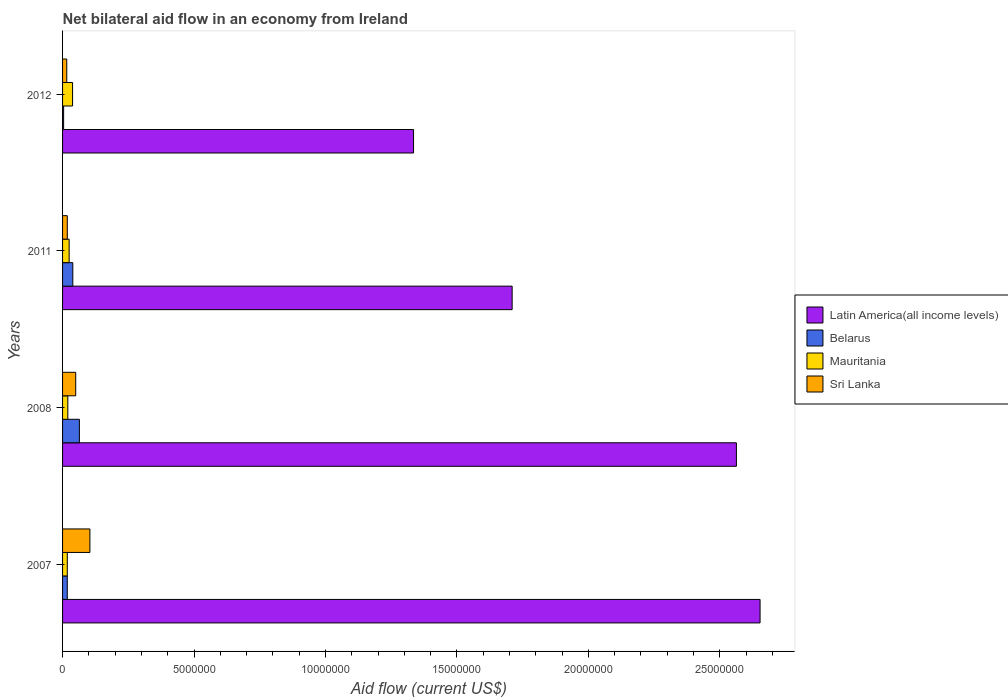How many groups of bars are there?
Make the answer very short. 4. Are the number of bars on each tick of the Y-axis equal?
Ensure brevity in your answer.  Yes. How many bars are there on the 2nd tick from the bottom?
Your answer should be compact. 4. In how many cases, is the number of bars for a given year not equal to the number of legend labels?
Give a very brief answer. 0. What is the net bilateral aid flow in Belarus in 2012?
Provide a succinct answer. 4.00e+04. Across all years, what is the minimum net bilateral aid flow in Mauritania?
Make the answer very short. 1.80e+05. In which year was the net bilateral aid flow in Sri Lanka minimum?
Make the answer very short. 2012. What is the total net bilateral aid flow in Belarus in the graph?
Offer a very short reply. 1.25e+06. What is the difference between the net bilateral aid flow in Latin America(all income levels) in 2007 and that in 2012?
Make the answer very short. 1.32e+07. What is the difference between the net bilateral aid flow in Latin America(all income levels) in 2011 and the net bilateral aid flow in Sri Lanka in 2007?
Your response must be concise. 1.61e+07. What is the average net bilateral aid flow in Belarus per year?
Offer a very short reply. 3.12e+05. What is the ratio of the net bilateral aid flow in Latin America(all income levels) in 2007 to that in 2008?
Offer a terse response. 1.04. Is the net bilateral aid flow in Mauritania in 2008 less than that in 2011?
Provide a succinct answer. Yes. What is the difference between the highest and the second highest net bilateral aid flow in Sri Lanka?
Provide a short and direct response. 5.40e+05. What is the difference between the highest and the lowest net bilateral aid flow in Mauritania?
Provide a short and direct response. 2.00e+05. In how many years, is the net bilateral aid flow in Latin America(all income levels) greater than the average net bilateral aid flow in Latin America(all income levels) taken over all years?
Give a very brief answer. 2. Is the sum of the net bilateral aid flow in Belarus in 2008 and 2011 greater than the maximum net bilateral aid flow in Latin America(all income levels) across all years?
Offer a very short reply. No. Is it the case that in every year, the sum of the net bilateral aid flow in Belarus and net bilateral aid flow in Sri Lanka is greater than the sum of net bilateral aid flow in Mauritania and net bilateral aid flow in Latin America(all income levels)?
Ensure brevity in your answer.  No. What does the 1st bar from the top in 2007 represents?
Your answer should be compact. Sri Lanka. What does the 1st bar from the bottom in 2007 represents?
Keep it short and to the point. Latin America(all income levels). Is it the case that in every year, the sum of the net bilateral aid flow in Latin America(all income levels) and net bilateral aid flow in Mauritania is greater than the net bilateral aid flow in Belarus?
Your answer should be very brief. Yes. How many bars are there?
Offer a terse response. 16. Are all the bars in the graph horizontal?
Your answer should be compact. Yes. What is the difference between two consecutive major ticks on the X-axis?
Provide a succinct answer. 5.00e+06. Are the values on the major ticks of X-axis written in scientific E-notation?
Make the answer very short. No. Does the graph contain any zero values?
Your answer should be very brief. No. How are the legend labels stacked?
Make the answer very short. Vertical. What is the title of the graph?
Provide a succinct answer. Net bilateral aid flow in an economy from Ireland. Does "South Asia" appear as one of the legend labels in the graph?
Provide a succinct answer. No. What is the label or title of the X-axis?
Offer a very short reply. Aid flow (current US$). What is the Aid flow (current US$) of Latin America(all income levels) in 2007?
Provide a succinct answer. 2.65e+07. What is the Aid flow (current US$) of Belarus in 2007?
Give a very brief answer. 1.80e+05. What is the Aid flow (current US$) in Mauritania in 2007?
Ensure brevity in your answer.  1.80e+05. What is the Aid flow (current US$) in Sri Lanka in 2007?
Give a very brief answer. 1.04e+06. What is the Aid flow (current US$) of Latin America(all income levels) in 2008?
Offer a very short reply. 2.56e+07. What is the Aid flow (current US$) of Belarus in 2008?
Ensure brevity in your answer.  6.40e+05. What is the Aid flow (current US$) in Sri Lanka in 2008?
Your answer should be very brief. 5.00e+05. What is the Aid flow (current US$) of Latin America(all income levels) in 2011?
Make the answer very short. 1.71e+07. What is the Aid flow (current US$) of Sri Lanka in 2011?
Give a very brief answer. 1.80e+05. What is the Aid flow (current US$) of Latin America(all income levels) in 2012?
Make the answer very short. 1.34e+07. What is the Aid flow (current US$) in Belarus in 2012?
Your answer should be very brief. 4.00e+04. Across all years, what is the maximum Aid flow (current US$) of Latin America(all income levels)?
Keep it short and to the point. 2.65e+07. Across all years, what is the maximum Aid flow (current US$) in Belarus?
Offer a terse response. 6.40e+05. Across all years, what is the maximum Aid flow (current US$) of Mauritania?
Make the answer very short. 3.80e+05. Across all years, what is the maximum Aid flow (current US$) of Sri Lanka?
Provide a succinct answer. 1.04e+06. Across all years, what is the minimum Aid flow (current US$) of Latin America(all income levels)?
Your answer should be compact. 1.34e+07. What is the total Aid flow (current US$) of Latin America(all income levels) in the graph?
Provide a short and direct response. 8.26e+07. What is the total Aid flow (current US$) of Belarus in the graph?
Make the answer very short. 1.25e+06. What is the total Aid flow (current US$) in Mauritania in the graph?
Keep it short and to the point. 1.01e+06. What is the total Aid flow (current US$) of Sri Lanka in the graph?
Your response must be concise. 1.88e+06. What is the difference between the Aid flow (current US$) of Belarus in 2007 and that in 2008?
Offer a very short reply. -4.60e+05. What is the difference between the Aid flow (current US$) of Mauritania in 2007 and that in 2008?
Your answer should be compact. -2.00e+04. What is the difference between the Aid flow (current US$) in Sri Lanka in 2007 and that in 2008?
Your answer should be compact. 5.40e+05. What is the difference between the Aid flow (current US$) in Latin America(all income levels) in 2007 and that in 2011?
Ensure brevity in your answer.  9.43e+06. What is the difference between the Aid flow (current US$) in Mauritania in 2007 and that in 2011?
Your answer should be compact. -7.00e+04. What is the difference between the Aid flow (current US$) of Sri Lanka in 2007 and that in 2011?
Offer a terse response. 8.60e+05. What is the difference between the Aid flow (current US$) of Latin America(all income levels) in 2007 and that in 2012?
Your response must be concise. 1.32e+07. What is the difference between the Aid flow (current US$) in Mauritania in 2007 and that in 2012?
Provide a short and direct response. -2.00e+05. What is the difference between the Aid flow (current US$) of Sri Lanka in 2007 and that in 2012?
Your answer should be compact. 8.80e+05. What is the difference between the Aid flow (current US$) in Latin America(all income levels) in 2008 and that in 2011?
Keep it short and to the point. 8.53e+06. What is the difference between the Aid flow (current US$) in Latin America(all income levels) in 2008 and that in 2012?
Give a very brief answer. 1.23e+07. What is the difference between the Aid flow (current US$) of Belarus in 2008 and that in 2012?
Your answer should be compact. 6.00e+05. What is the difference between the Aid flow (current US$) in Sri Lanka in 2008 and that in 2012?
Ensure brevity in your answer.  3.40e+05. What is the difference between the Aid flow (current US$) in Latin America(all income levels) in 2011 and that in 2012?
Keep it short and to the point. 3.75e+06. What is the difference between the Aid flow (current US$) in Belarus in 2011 and that in 2012?
Keep it short and to the point. 3.50e+05. What is the difference between the Aid flow (current US$) of Sri Lanka in 2011 and that in 2012?
Keep it short and to the point. 2.00e+04. What is the difference between the Aid flow (current US$) of Latin America(all income levels) in 2007 and the Aid flow (current US$) of Belarus in 2008?
Your answer should be compact. 2.59e+07. What is the difference between the Aid flow (current US$) of Latin America(all income levels) in 2007 and the Aid flow (current US$) of Mauritania in 2008?
Keep it short and to the point. 2.63e+07. What is the difference between the Aid flow (current US$) of Latin America(all income levels) in 2007 and the Aid flow (current US$) of Sri Lanka in 2008?
Offer a terse response. 2.60e+07. What is the difference between the Aid flow (current US$) in Belarus in 2007 and the Aid flow (current US$) in Mauritania in 2008?
Make the answer very short. -2.00e+04. What is the difference between the Aid flow (current US$) in Belarus in 2007 and the Aid flow (current US$) in Sri Lanka in 2008?
Provide a short and direct response. -3.20e+05. What is the difference between the Aid flow (current US$) in Mauritania in 2007 and the Aid flow (current US$) in Sri Lanka in 2008?
Ensure brevity in your answer.  -3.20e+05. What is the difference between the Aid flow (current US$) of Latin America(all income levels) in 2007 and the Aid flow (current US$) of Belarus in 2011?
Offer a terse response. 2.61e+07. What is the difference between the Aid flow (current US$) in Latin America(all income levels) in 2007 and the Aid flow (current US$) in Mauritania in 2011?
Your answer should be very brief. 2.63e+07. What is the difference between the Aid flow (current US$) of Latin America(all income levels) in 2007 and the Aid flow (current US$) of Sri Lanka in 2011?
Your response must be concise. 2.64e+07. What is the difference between the Aid flow (current US$) of Latin America(all income levels) in 2007 and the Aid flow (current US$) of Belarus in 2012?
Give a very brief answer. 2.65e+07. What is the difference between the Aid flow (current US$) of Latin America(all income levels) in 2007 and the Aid flow (current US$) of Mauritania in 2012?
Offer a very short reply. 2.62e+07. What is the difference between the Aid flow (current US$) in Latin America(all income levels) in 2007 and the Aid flow (current US$) in Sri Lanka in 2012?
Provide a short and direct response. 2.64e+07. What is the difference between the Aid flow (current US$) in Latin America(all income levels) in 2008 and the Aid flow (current US$) in Belarus in 2011?
Your answer should be compact. 2.52e+07. What is the difference between the Aid flow (current US$) in Latin America(all income levels) in 2008 and the Aid flow (current US$) in Mauritania in 2011?
Make the answer very short. 2.54e+07. What is the difference between the Aid flow (current US$) in Latin America(all income levels) in 2008 and the Aid flow (current US$) in Sri Lanka in 2011?
Provide a succinct answer. 2.54e+07. What is the difference between the Aid flow (current US$) of Latin America(all income levels) in 2008 and the Aid flow (current US$) of Belarus in 2012?
Ensure brevity in your answer.  2.56e+07. What is the difference between the Aid flow (current US$) in Latin America(all income levels) in 2008 and the Aid flow (current US$) in Mauritania in 2012?
Make the answer very short. 2.52e+07. What is the difference between the Aid flow (current US$) of Latin America(all income levels) in 2008 and the Aid flow (current US$) of Sri Lanka in 2012?
Offer a very short reply. 2.55e+07. What is the difference between the Aid flow (current US$) in Mauritania in 2008 and the Aid flow (current US$) in Sri Lanka in 2012?
Make the answer very short. 4.00e+04. What is the difference between the Aid flow (current US$) in Latin America(all income levels) in 2011 and the Aid flow (current US$) in Belarus in 2012?
Provide a succinct answer. 1.71e+07. What is the difference between the Aid flow (current US$) in Latin America(all income levels) in 2011 and the Aid flow (current US$) in Mauritania in 2012?
Your answer should be very brief. 1.67e+07. What is the difference between the Aid flow (current US$) in Latin America(all income levels) in 2011 and the Aid flow (current US$) in Sri Lanka in 2012?
Provide a succinct answer. 1.69e+07. What is the difference between the Aid flow (current US$) of Mauritania in 2011 and the Aid flow (current US$) of Sri Lanka in 2012?
Give a very brief answer. 9.00e+04. What is the average Aid flow (current US$) in Latin America(all income levels) per year?
Ensure brevity in your answer.  2.07e+07. What is the average Aid flow (current US$) in Belarus per year?
Your answer should be very brief. 3.12e+05. What is the average Aid flow (current US$) of Mauritania per year?
Ensure brevity in your answer.  2.52e+05. What is the average Aid flow (current US$) in Sri Lanka per year?
Give a very brief answer. 4.70e+05. In the year 2007, what is the difference between the Aid flow (current US$) in Latin America(all income levels) and Aid flow (current US$) in Belarus?
Your answer should be compact. 2.64e+07. In the year 2007, what is the difference between the Aid flow (current US$) in Latin America(all income levels) and Aid flow (current US$) in Mauritania?
Offer a very short reply. 2.64e+07. In the year 2007, what is the difference between the Aid flow (current US$) of Latin America(all income levels) and Aid flow (current US$) of Sri Lanka?
Your answer should be very brief. 2.55e+07. In the year 2007, what is the difference between the Aid flow (current US$) in Belarus and Aid flow (current US$) in Mauritania?
Make the answer very short. 0. In the year 2007, what is the difference between the Aid flow (current US$) in Belarus and Aid flow (current US$) in Sri Lanka?
Your answer should be compact. -8.60e+05. In the year 2007, what is the difference between the Aid flow (current US$) of Mauritania and Aid flow (current US$) of Sri Lanka?
Provide a short and direct response. -8.60e+05. In the year 2008, what is the difference between the Aid flow (current US$) of Latin America(all income levels) and Aid flow (current US$) of Belarus?
Your answer should be very brief. 2.50e+07. In the year 2008, what is the difference between the Aid flow (current US$) of Latin America(all income levels) and Aid flow (current US$) of Mauritania?
Keep it short and to the point. 2.54e+07. In the year 2008, what is the difference between the Aid flow (current US$) of Latin America(all income levels) and Aid flow (current US$) of Sri Lanka?
Ensure brevity in your answer.  2.51e+07. In the year 2008, what is the difference between the Aid flow (current US$) of Belarus and Aid flow (current US$) of Mauritania?
Provide a succinct answer. 4.40e+05. In the year 2011, what is the difference between the Aid flow (current US$) in Latin America(all income levels) and Aid flow (current US$) in Belarus?
Keep it short and to the point. 1.67e+07. In the year 2011, what is the difference between the Aid flow (current US$) of Latin America(all income levels) and Aid flow (current US$) of Mauritania?
Your answer should be very brief. 1.68e+07. In the year 2011, what is the difference between the Aid flow (current US$) in Latin America(all income levels) and Aid flow (current US$) in Sri Lanka?
Your answer should be very brief. 1.69e+07. In the year 2012, what is the difference between the Aid flow (current US$) in Latin America(all income levels) and Aid flow (current US$) in Belarus?
Ensure brevity in your answer.  1.33e+07. In the year 2012, what is the difference between the Aid flow (current US$) of Latin America(all income levels) and Aid flow (current US$) of Mauritania?
Make the answer very short. 1.30e+07. In the year 2012, what is the difference between the Aid flow (current US$) in Latin America(all income levels) and Aid flow (current US$) in Sri Lanka?
Make the answer very short. 1.32e+07. In the year 2012, what is the difference between the Aid flow (current US$) of Belarus and Aid flow (current US$) of Sri Lanka?
Keep it short and to the point. -1.20e+05. In the year 2012, what is the difference between the Aid flow (current US$) of Mauritania and Aid flow (current US$) of Sri Lanka?
Make the answer very short. 2.20e+05. What is the ratio of the Aid flow (current US$) of Latin America(all income levels) in 2007 to that in 2008?
Your answer should be compact. 1.04. What is the ratio of the Aid flow (current US$) in Belarus in 2007 to that in 2008?
Your response must be concise. 0.28. What is the ratio of the Aid flow (current US$) of Sri Lanka in 2007 to that in 2008?
Offer a terse response. 2.08. What is the ratio of the Aid flow (current US$) of Latin America(all income levels) in 2007 to that in 2011?
Give a very brief answer. 1.55. What is the ratio of the Aid flow (current US$) in Belarus in 2007 to that in 2011?
Provide a short and direct response. 0.46. What is the ratio of the Aid flow (current US$) in Mauritania in 2007 to that in 2011?
Your response must be concise. 0.72. What is the ratio of the Aid flow (current US$) of Sri Lanka in 2007 to that in 2011?
Your answer should be compact. 5.78. What is the ratio of the Aid flow (current US$) in Latin America(all income levels) in 2007 to that in 2012?
Ensure brevity in your answer.  1.99. What is the ratio of the Aid flow (current US$) of Mauritania in 2007 to that in 2012?
Ensure brevity in your answer.  0.47. What is the ratio of the Aid flow (current US$) of Latin America(all income levels) in 2008 to that in 2011?
Keep it short and to the point. 1.5. What is the ratio of the Aid flow (current US$) in Belarus in 2008 to that in 2011?
Your answer should be compact. 1.64. What is the ratio of the Aid flow (current US$) in Sri Lanka in 2008 to that in 2011?
Keep it short and to the point. 2.78. What is the ratio of the Aid flow (current US$) in Latin America(all income levels) in 2008 to that in 2012?
Offer a terse response. 1.92. What is the ratio of the Aid flow (current US$) of Belarus in 2008 to that in 2012?
Ensure brevity in your answer.  16. What is the ratio of the Aid flow (current US$) of Mauritania in 2008 to that in 2012?
Your answer should be compact. 0.53. What is the ratio of the Aid flow (current US$) in Sri Lanka in 2008 to that in 2012?
Provide a short and direct response. 3.12. What is the ratio of the Aid flow (current US$) of Latin America(all income levels) in 2011 to that in 2012?
Give a very brief answer. 1.28. What is the ratio of the Aid flow (current US$) in Belarus in 2011 to that in 2012?
Provide a short and direct response. 9.75. What is the ratio of the Aid flow (current US$) in Mauritania in 2011 to that in 2012?
Offer a very short reply. 0.66. What is the difference between the highest and the second highest Aid flow (current US$) of Latin America(all income levels)?
Offer a very short reply. 9.00e+05. What is the difference between the highest and the second highest Aid flow (current US$) in Sri Lanka?
Keep it short and to the point. 5.40e+05. What is the difference between the highest and the lowest Aid flow (current US$) in Latin America(all income levels)?
Provide a succinct answer. 1.32e+07. What is the difference between the highest and the lowest Aid flow (current US$) in Sri Lanka?
Ensure brevity in your answer.  8.80e+05. 